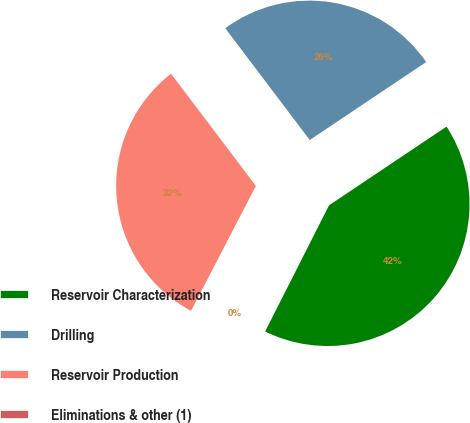<chart> <loc_0><loc_0><loc_500><loc_500><pie_chart><fcel>Reservoir Characterization<fcel>Drilling<fcel>Reservoir Production<fcel>Eliminations & other (1)<nl><fcel>41.86%<fcel>25.91%<fcel>32.08%<fcel>0.16%<nl></chart> 